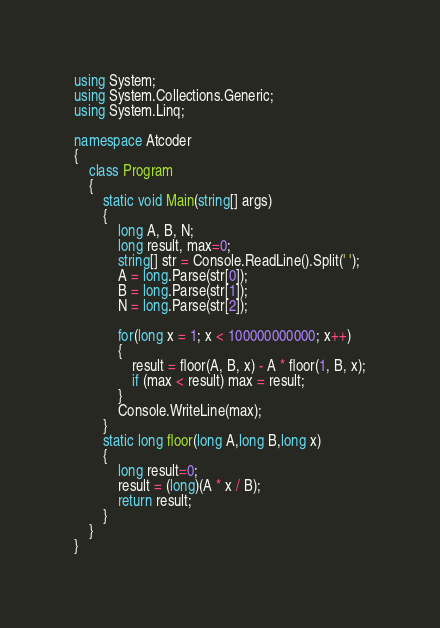<code> <loc_0><loc_0><loc_500><loc_500><_C#_>using System;
using System.Collections.Generic;
using System.Linq;

namespace Atcoder
{
    class Program
    {
        static void Main(string[] args)
        {
            long A, B, N;
            long result, max=0;
            string[] str = Console.ReadLine().Split(' ');
            A = long.Parse(str[0]);
            B = long.Parse(str[1]);
            N = long.Parse(str[2]);

            for(long x = 1; x < 100000000000; x++)
            {
                result = floor(A, B, x) - A * floor(1, B, x);
                if (max < result) max = result;
            }
            Console.WriteLine(max);
        }
        static long floor(long A,long B,long x)
        {
            long result=0;
            result = (long)(A * x / B);
            return result;
        }
    }
}
</code> 